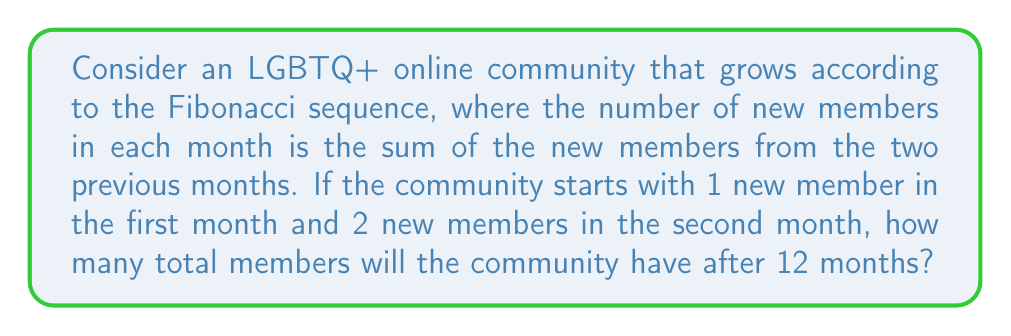Show me your answer to this math problem. Let's approach this step-by-step:

1) First, let's write out the Fibonacci sequence for the first 12 months:

   Month 1: 1
   Month 2: 2
   Month 3: 1 + 2 = 3
   Month 4: 2 + 3 = 5
   Month 5: 3 + 5 = 8
   Month 6: 5 + 8 = 13
   Month 7: 8 + 13 = 21
   Month 8: 13 + 21 = 34
   Month 9: 21 + 34 = 55
   Month 10: 34 + 55 = 89
   Month 11: 55 + 89 = 144
   Month 12: 89 + 144 = 233

2) This sequence represents the number of new members joining each month.

3) To find the total number of members after 12 months, we need to sum all these numbers:

   $$\sum_{i=1}^{12} F_i = 1 + 2 + 3 + 5 + 8 + 13 + 21 + 34 + 55 + 89 + 144 + 233$$

4) There's a fascinating property of the Fibonacci sequence that can help us here. The sum of the first n Fibonacci numbers is equal to the (n+2)th Fibonacci number minus 1.

5) In mathematical notation:

   $$\sum_{i=1}^{n} F_i = F_{n+2} - 1$$

6) In our case, n = 12, so we need to find the 14th Fibonacci number:

   F_13 = 233 + 144 = 377
   F_14 = 377 + 233 = 610

7) Therefore, the sum of the first 12 Fibonacci numbers is:

   $$\sum_{i=1}^{12} F_i = F_{14} - 1 = 610 - 1 = 609$$

Thus, after 12 months, the online community will have 609 total members.
Answer: 609 